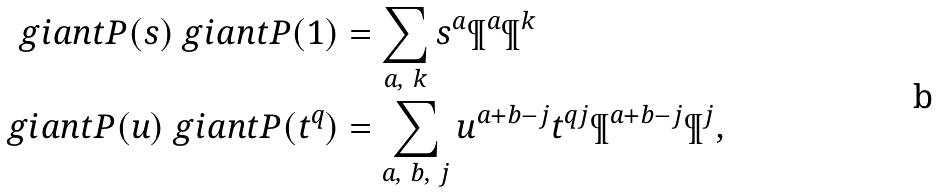<formula> <loc_0><loc_0><loc_500><loc_500>\ g i a n t P ( s ) \ g i a n t P ( 1 ) & = \sum _ { a , \ k } s ^ { a } \P ^ { a } \P ^ { k } \\ \ g i a n t P ( u ) \ g i a n t P ( t ^ { q } ) & = \sum _ { a , \ b , \ j } u ^ { a + b - j } t ^ { q j } \P ^ { a + b - j } \P ^ { j } ,</formula> 